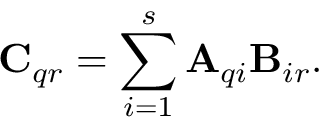<formula> <loc_0><loc_0><loc_500><loc_500>C _ { q r } = \sum _ { i = 1 } ^ { s } A _ { q i } B _ { i r } .</formula> 